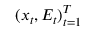<formula> <loc_0><loc_0><loc_500><loc_500>( x _ { t } , E _ { t } ) _ { t = 1 } ^ { T }</formula> 